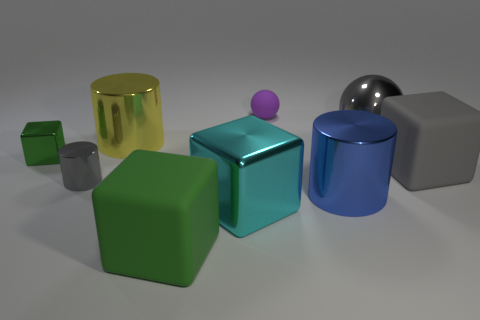Is the number of purple spheres greater than the number of purple cylinders?
Make the answer very short. Yes. The blue metallic cylinder has what size?
Your response must be concise. Large. How many other objects are the same color as the big shiny cube?
Give a very brief answer. 0. Are the thing that is behind the big gray metal ball and the gray block made of the same material?
Your answer should be very brief. Yes. Is the number of large blue shiny objects to the left of the gray metal cylinder less than the number of things in front of the big cyan object?
Provide a succinct answer. Yes. What number of other objects are the same material as the purple thing?
Ensure brevity in your answer.  2. What is the material of the green block that is the same size as the blue shiny thing?
Provide a succinct answer. Rubber. Are there fewer gray blocks in front of the big gray rubber block than small green things?
Make the answer very short. Yes. What shape is the small shiny object that is in front of the green block left of the gray shiny thing that is in front of the big gray metal sphere?
Provide a short and direct response. Cylinder. What size is the yellow thing to the left of the large green rubber thing?
Ensure brevity in your answer.  Large. 